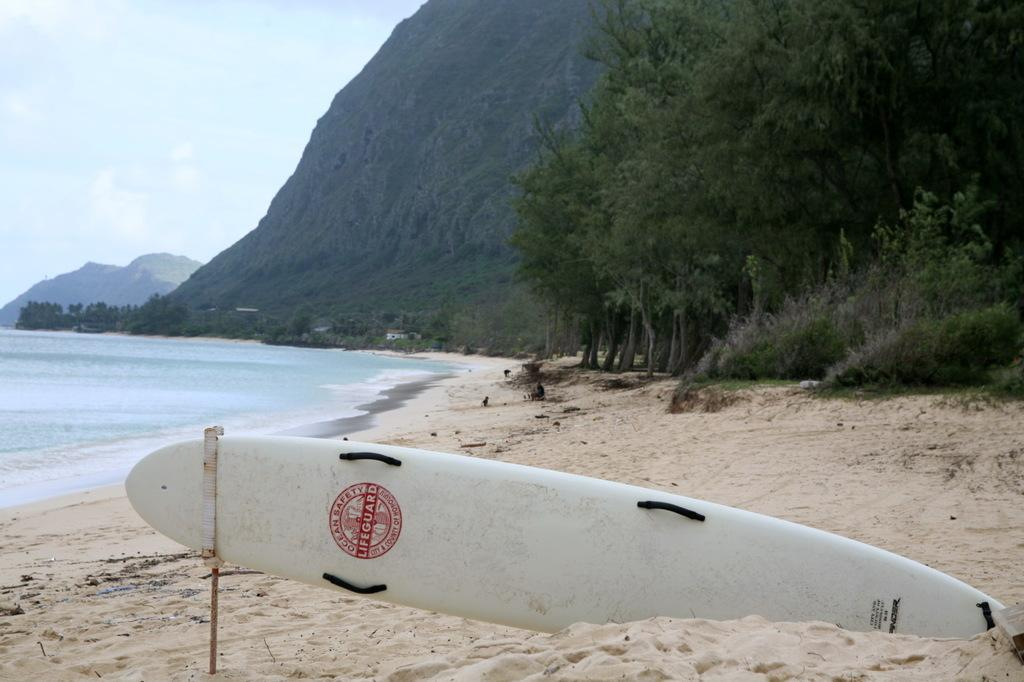What type of location is depicted in the image? There is a beach in the image. What can be seen surrounding the beach? The beach is surrounded by greenery. What is a characteristic of the beach's surface? There is sand on the beach. What recreational item is present on the beach? A surfing board is present on the beach. Who is sitting on the throne on the beach in the image? There is no throne present on the beach in the image. 